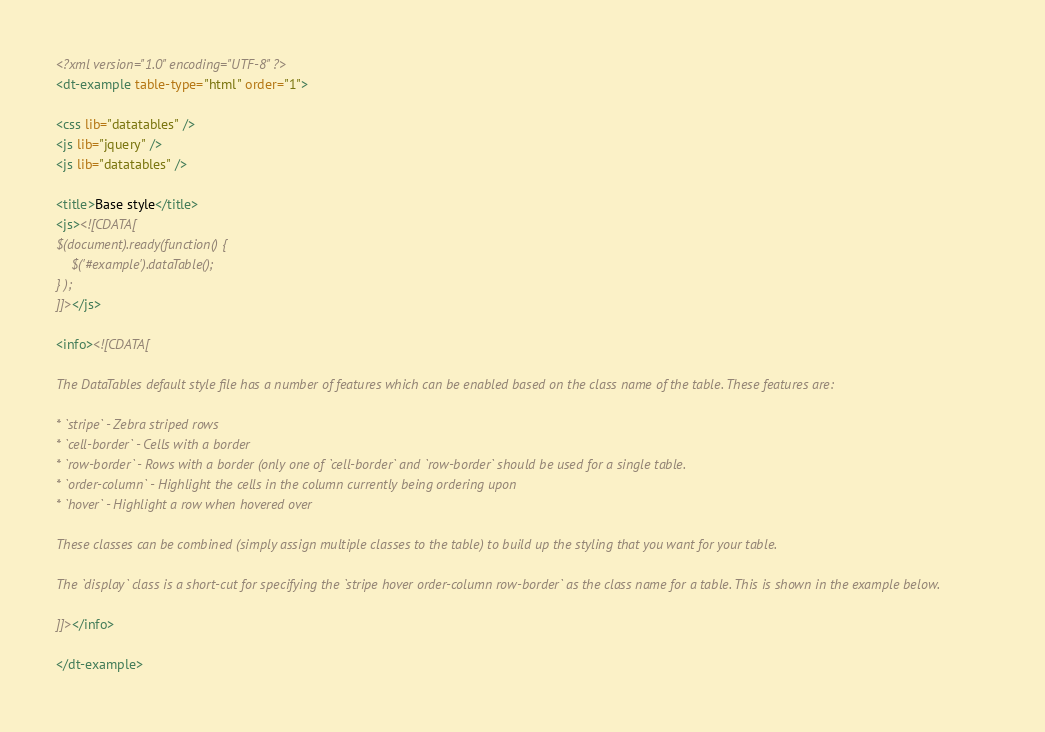Convert code to text. <code><loc_0><loc_0><loc_500><loc_500><_XML_><?xml version="1.0" encoding="UTF-8" ?>
<dt-example table-type="html" order="1">

<css lib="datatables" />
<js lib="jquery" />
<js lib="datatables" />

<title>Base style</title>
<js><![CDATA[
$(document).ready(function() {
	$('#example').dataTable();
} );
]]></js>

<info><![CDATA[

The DataTables default style file has a number of features which can be enabled based on the class name of the table. These features are:

* `stripe` - Zebra striped rows
* `cell-border` - Cells with a border
* `row-border` - Rows with a border (only one of `cell-border` and `row-border` should be used for a single table.
* `order-column` - Highlight the cells in the column currently being ordering upon
* `hover` - Highlight a row when hovered over

These classes can be combined (simply assign multiple classes to the table) to build up the styling that you want for your table.

The `display` class is a short-cut for specifying the `stripe hover order-column row-border` as the class name for a table. This is shown in the example below.

]]></info>

</dt-example>
</code> 